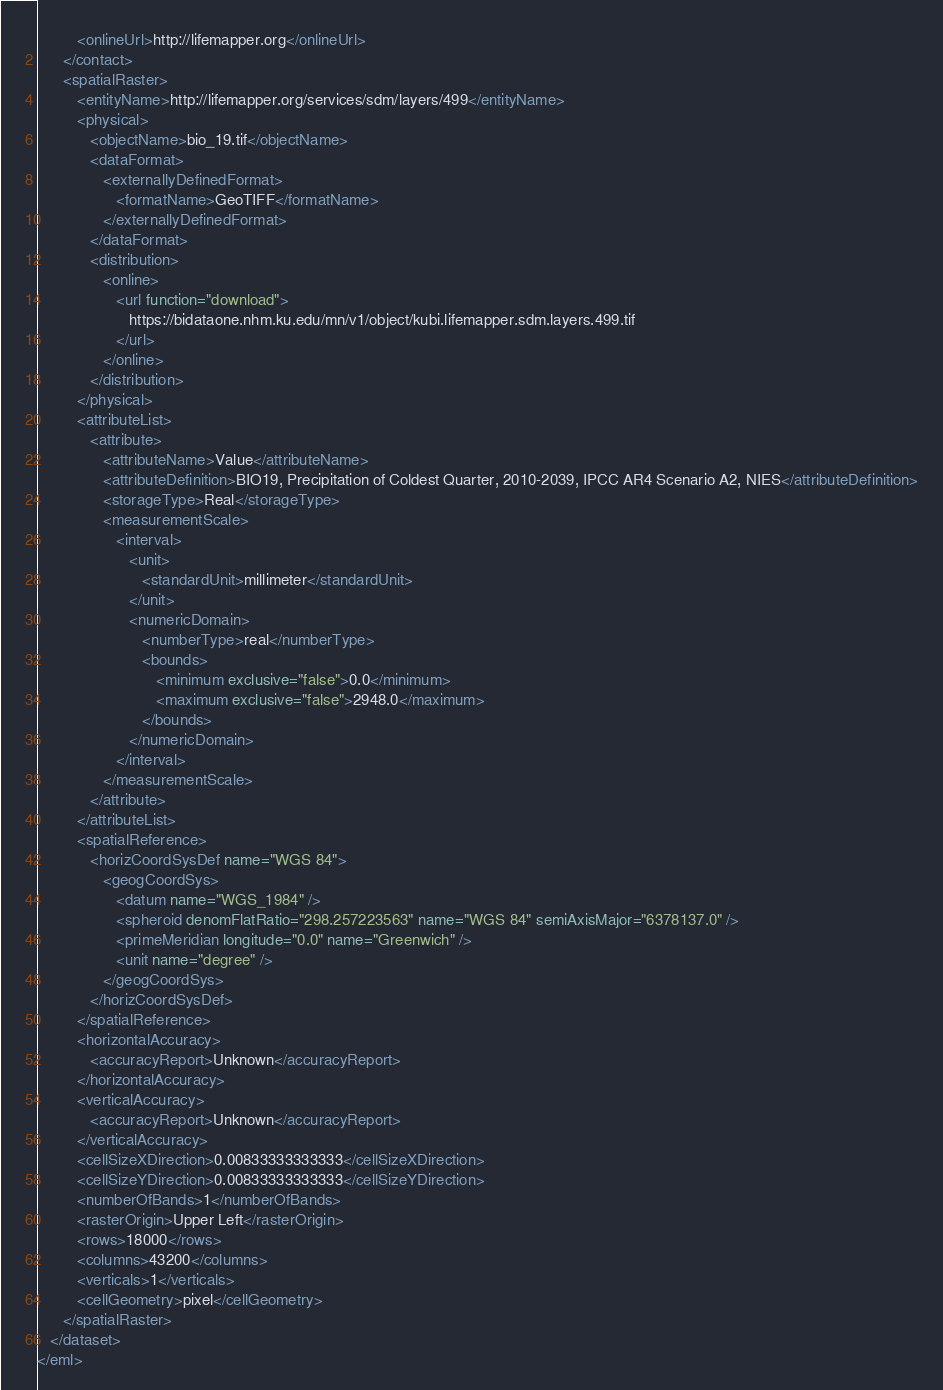Convert code to text. <code><loc_0><loc_0><loc_500><loc_500><_XML_>         <onlineUrl>http://lifemapper.org</onlineUrl>
      </contact>
      <spatialRaster>
         <entityName>http://lifemapper.org/services/sdm/layers/499</entityName>
         <physical>
            <objectName>bio_19.tif</objectName>
            <dataFormat>
               <externallyDefinedFormat>
                  <formatName>GeoTIFF</formatName>
               </externallyDefinedFormat>
            </dataFormat>
            <distribution>
               <online>
                  <url function="download">
                     https://bidataone.nhm.ku.edu/mn/v1/object/kubi.lifemapper.sdm.layers.499.tif
                  </url>
               </online>
            </distribution>
         </physical>
         <attributeList>
            <attribute>
               <attributeName>Value</attributeName>
               <attributeDefinition>BIO19, Precipitation of Coldest Quarter, 2010-2039, IPCC AR4 Scenario A2, NIES</attributeDefinition>
               <storageType>Real</storageType>
               <measurementScale>
                  <interval>
                     <unit>
                        <standardUnit>millimeter</standardUnit>
                     </unit>
                     <numericDomain>
                        <numberType>real</numberType>
                        <bounds>
                           <minimum exclusive="false">0.0</minimum>
                           <maximum exclusive="false">2948.0</maximum>
                        </bounds>
                     </numericDomain>
                  </interval>
               </measurementScale>
            </attribute>
         </attributeList>
         <spatialReference>
            <horizCoordSysDef name="WGS 84">
               <geogCoordSys>
                  <datum name="WGS_1984" />
                  <spheroid denomFlatRatio="298.257223563" name="WGS 84" semiAxisMajor="6378137.0" />
                  <primeMeridian longitude="0.0" name="Greenwich" />
                  <unit name="degree" />
               </geogCoordSys>
            </horizCoordSysDef>
         </spatialReference>
         <horizontalAccuracy>
            <accuracyReport>Unknown</accuracyReport>
         </horizontalAccuracy>
         <verticalAccuracy>
            <accuracyReport>Unknown</accuracyReport>
         </verticalAccuracy>
         <cellSizeXDirection>0.00833333333333</cellSizeXDirection>
         <cellSizeYDirection>0.00833333333333</cellSizeYDirection>
         <numberOfBands>1</numberOfBands>
         <rasterOrigin>Upper Left</rasterOrigin>
         <rows>18000</rows>
         <columns>43200</columns>
         <verticals>1</verticals>
         <cellGeometry>pixel</cellGeometry>
      </spatialRaster>
   </dataset>
</eml></code> 